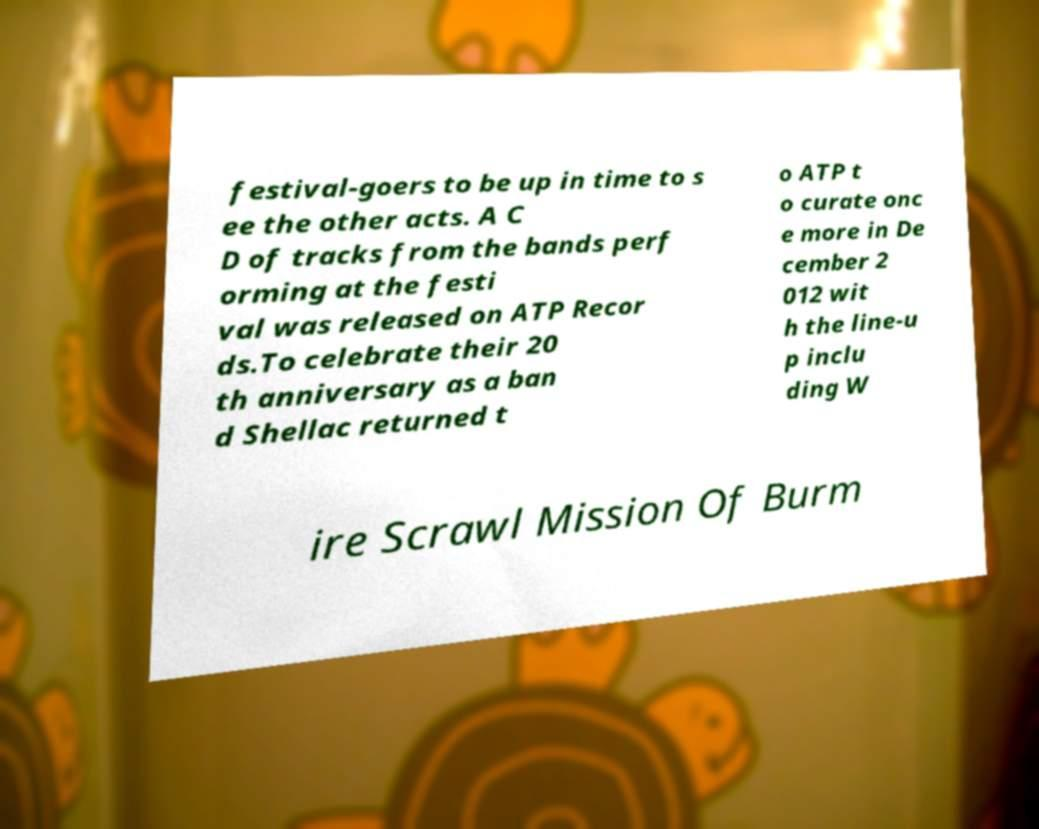I need the written content from this picture converted into text. Can you do that? festival-goers to be up in time to s ee the other acts. A C D of tracks from the bands perf orming at the festi val was released on ATP Recor ds.To celebrate their 20 th anniversary as a ban d Shellac returned t o ATP t o curate onc e more in De cember 2 012 wit h the line-u p inclu ding W ire Scrawl Mission Of Burm 